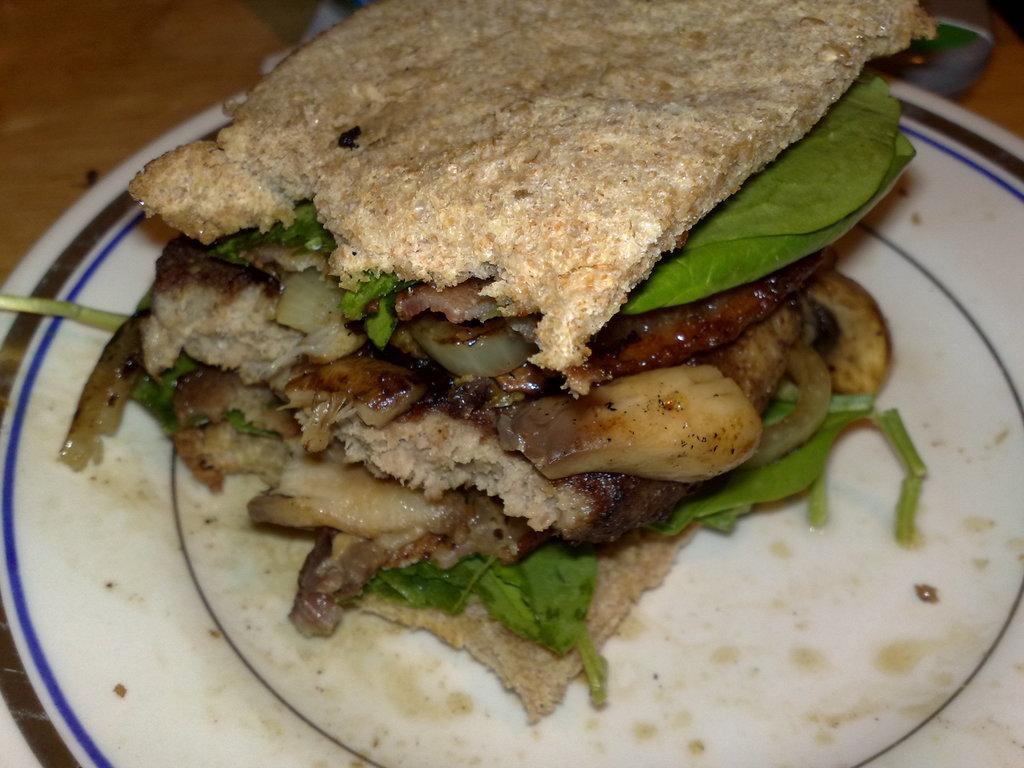What object is present in the image that typically holds food? There is a plate in the image. What is on the plate in the image? The plate contains food. How does the plate maintain a quiet atmosphere in the image? The plate does not maintain a quiet atmosphere in the image; it is an inanimate object and cannot influence the sound level. 